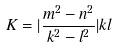<formula> <loc_0><loc_0><loc_500><loc_500>K = | \frac { m ^ { 2 } - n ^ { 2 } } { k ^ { 2 } - l ^ { 2 } } | k l</formula> 